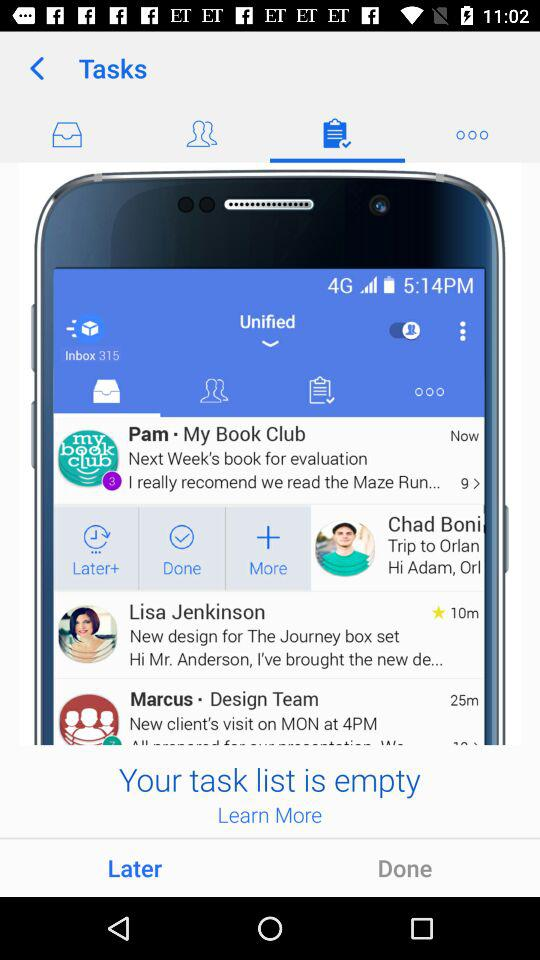Is there any task list?
When the provided information is insufficient, respond with <no answer>. <no answer> 